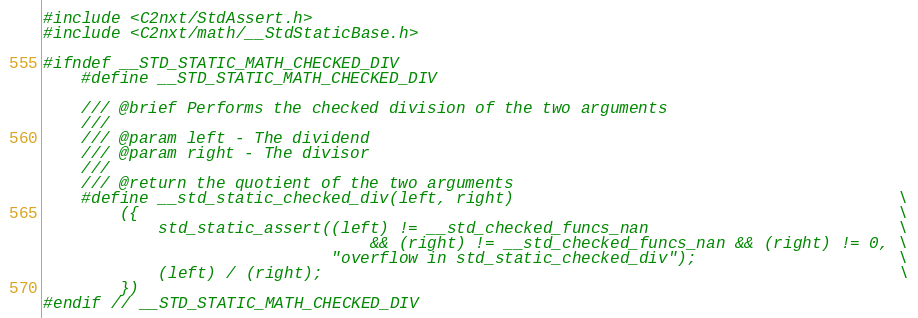Convert code to text. <code><loc_0><loc_0><loc_500><loc_500><_C_>
#include <C2nxt/StdAssert.h>
#include <C2nxt/math/__StdStaticBase.h>

#ifndef __STD_STATIC_MATH_CHECKED_DIV
	#define __STD_STATIC_MATH_CHECKED_DIV

	/// @brief Performs the checked division of the two arguments
	///
	/// @param left - The dividend
	/// @param right - The divisor
	///
	/// @return the quotient of the two arguments
	#define __std_static_checked_div(left, right)                                        \
		({                                                                               \
			std_static_assert((left) != __std_checked_funcs_nan                          \
								  && (right) != __std_checked_funcs_nan && (right) != 0, \
							  "overflow in std_static_checked_div");                     \
			(left) / (right);                                                            \
		})
#endif // __STD_STATIC_MATH_CHECKED_DIV
</code> 